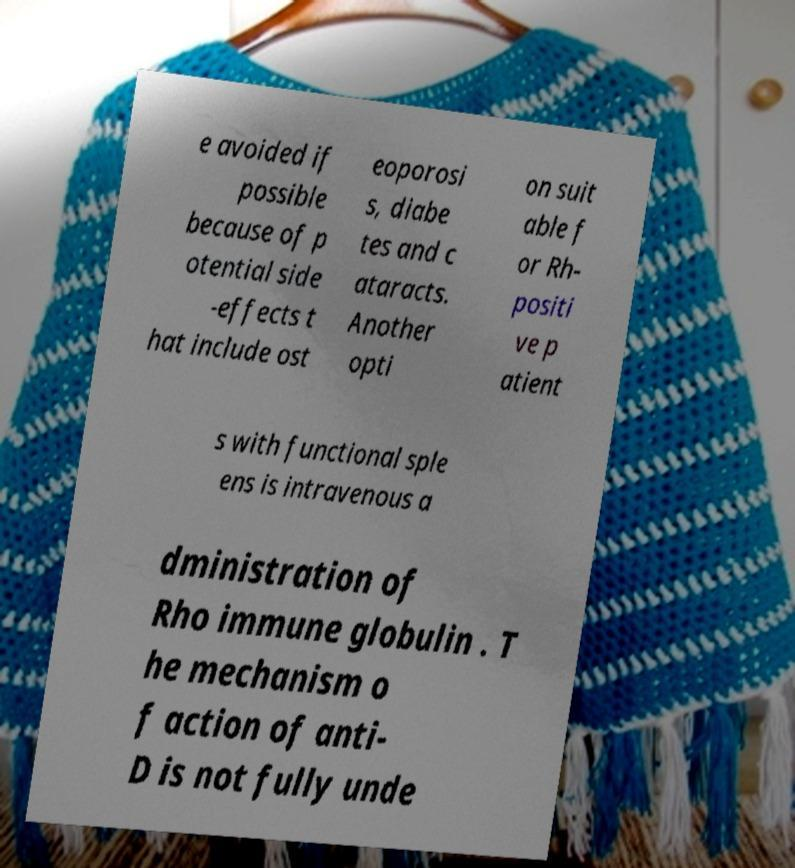For documentation purposes, I need the text within this image transcribed. Could you provide that? e avoided if possible because of p otential side -effects t hat include ost eoporosi s, diabe tes and c ataracts. Another opti on suit able f or Rh- positi ve p atient s with functional sple ens is intravenous a dministration of Rho immune globulin . T he mechanism o f action of anti- D is not fully unde 